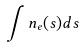<formula> <loc_0><loc_0><loc_500><loc_500>\int n _ { e } ( s ) d s</formula> 